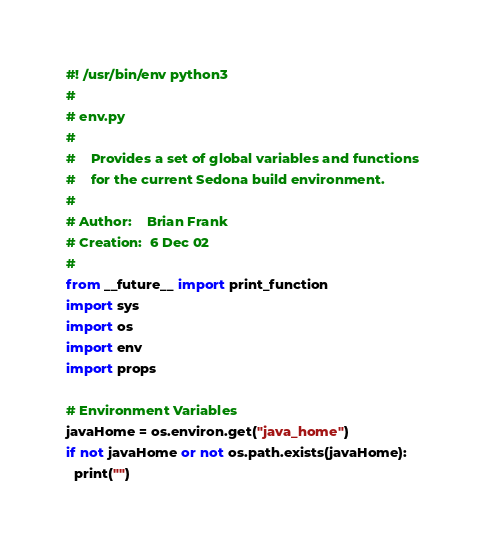Convert code to text. <code><loc_0><loc_0><loc_500><loc_500><_Python_>#! /usr/bin/env python3
#
# env.py
# 
#    Provides a set of global variables and functions
#    for the current Sedona build environment.
#
# Author:    Brian Frank
# Creation:  6 Dec 02
# 
from __future__ import print_function
import sys
import os           
import env
import props

# Environment Variables
javaHome = os.environ.get("java_home")
if not javaHome or not os.path.exists(javaHome):
  print("")</code> 